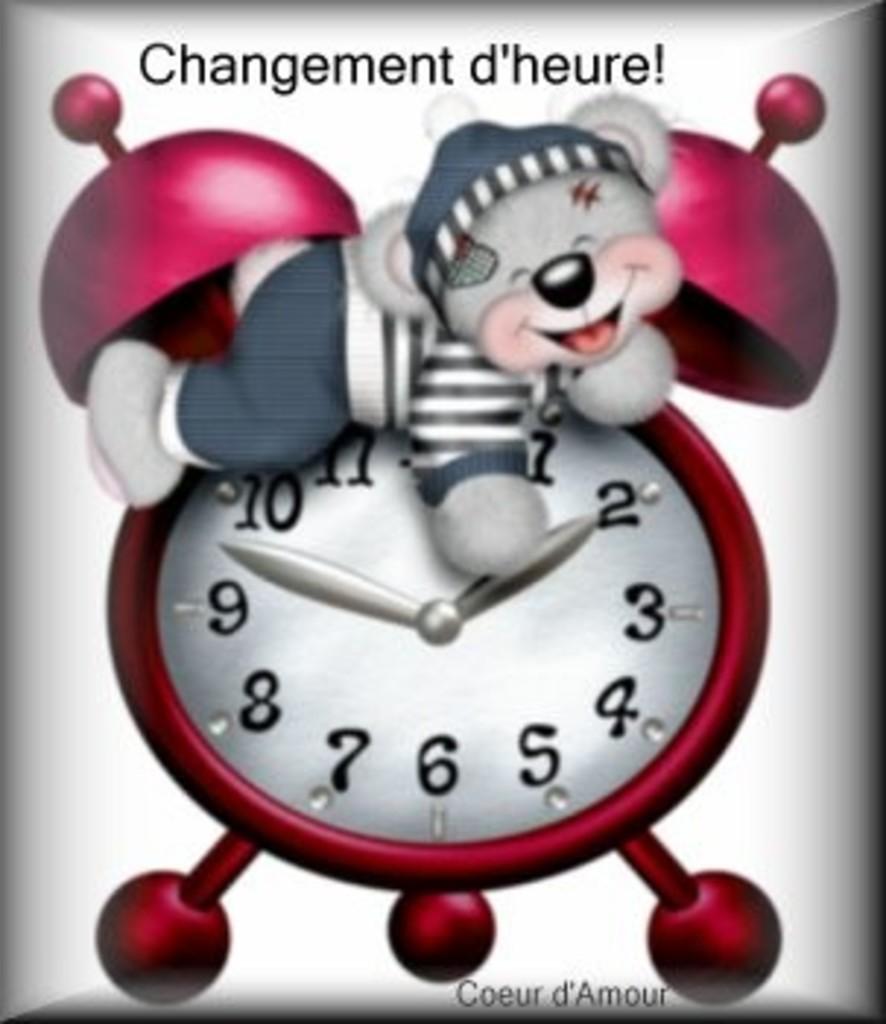What number is the small hand pointing at?
Offer a terse response. 2. What is this sign telling you to do?
Your answer should be very brief. Changement d'heure. 